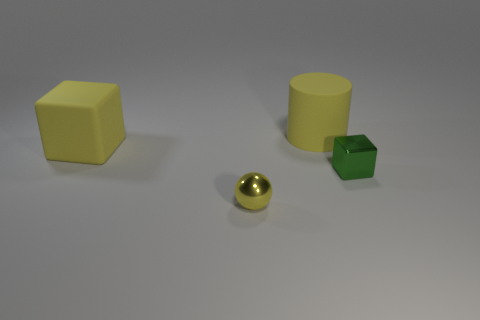How many other things are the same size as the cylinder?
Provide a short and direct response. 1. What is the shape of the small metal thing that is to the right of the yellow thing in front of the tiny thing that is behind the tiny yellow thing?
Provide a succinct answer. Cube. Does the yellow metal sphere have the same size as the yellow rubber thing that is to the left of the cylinder?
Your answer should be compact. No. There is a thing that is behind the green shiny cube and to the right of the tiny ball; what is its color?
Provide a short and direct response. Yellow. What number of other objects are there of the same shape as the small green object?
Make the answer very short. 1. Is the color of the cube that is behind the tiny green cube the same as the rubber thing to the right of the tiny yellow ball?
Your answer should be very brief. Yes. There is a metal thing in front of the small metal block; does it have the same size as the cube to the right of the metallic sphere?
Your answer should be compact. Yes. There is a small thing that is on the right side of the shiny thing that is in front of the block that is to the right of the ball; what is its material?
Provide a succinct answer. Metal. There is a big yellow thing that is the same shape as the small green metallic object; what is its material?
Offer a very short reply. Rubber. What number of big matte objects have the same color as the large rubber block?
Give a very brief answer. 1. 